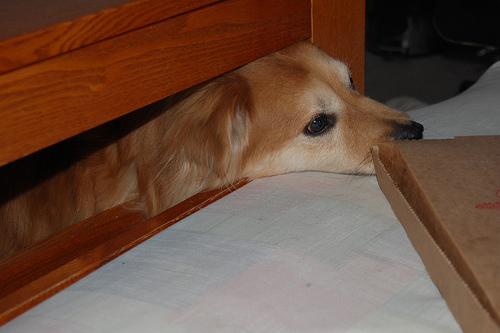<image>
Is the dog on the bed? No. The dog is not positioned on the bed. They may be near each other, but the dog is not supported by or resting on top of the bed. Is the dog in the bed? Yes. The dog is contained within or inside the bed, showing a containment relationship. 